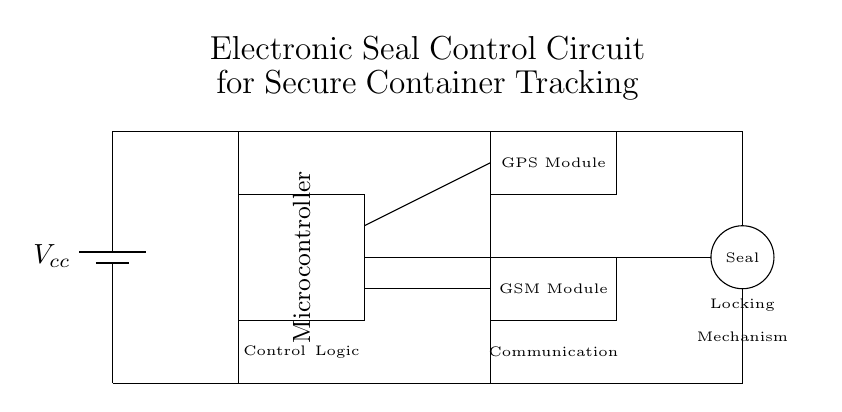What is the power supply used in this circuit? The circuit shows a battery labeled Vcc, which indicates that this is the power supply providing energy to the components of the circuit.
Answer: Vcc What components are connected to the microcontroller? The circuit diagram indicates that both the GPS Module and the GSM Module are connected to the microcontroller, as seen from the lines connecting them.
Answer: GPS Module, GSM Module What function does the seal mechanism serve? The seal mechanism is represented by a circle labeled "Seal," indicating it is used for securing the container. Its logic and control will be managed by the microcontroller in response to commands received from the GSM or GPS modules.
Answer: Securing the container How many modules are present in this circuit? The circuit diagram includes two modules: a GPS Module and a GSM Module, both of which provide tracking and communication capabilities.
Answer: Two modules What is the role of the communication section in the circuit? The communication section is represented by the GSM Module, which is connected to the microcontroller and plays a crucial role in sending data to external systems, thus facilitating real-time tracking of the secured container.
Answer: Sending data What type of connection does the microcontroller have to the seal mechanism? The microcontroller is connected directly to the seal mechanism through a line, indicating control over its operation. This implies that the microcontroller can activate or deactivate the seal based on conditions defined in the control logic.
Answer: Direct connection What is the primary logic component in this circuit? The circuit features a labeled area for Control Logic, which provides the decision-making capabilities necessary to manage the interactions between the components, ensuring secure tracking and sealing operations.
Answer: Control Logic 